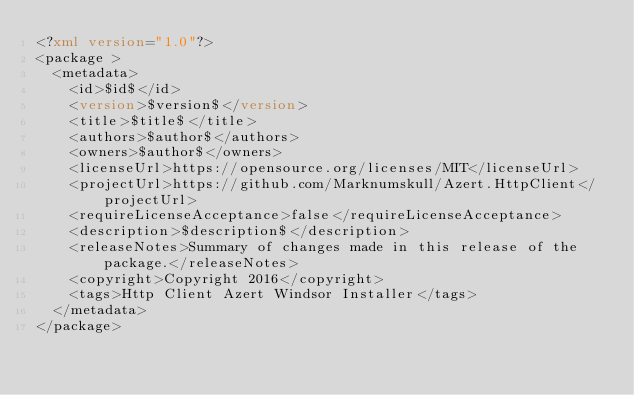<code> <loc_0><loc_0><loc_500><loc_500><_XML_><?xml version="1.0"?>
<package >
  <metadata>
    <id>$id$</id>
    <version>$version$</version>
    <title>$title$</title>
    <authors>$author$</authors>
    <owners>$author$</owners>
    <licenseUrl>https://opensource.org/licenses/MIT</licenseUrl>
    <projectUrl>https://github.com/Marknumskull/Azert.HttpClient</projectUrl>
    <requireLicenseAcceptance>false</requireLicenseAcceptance>
    <description>$description$</description>
    <releaseNotes>Summary of changes made in this release of the package.</releaseNotes>
    <copyright>Copyright 2016</copyright>
    <tags>Http Client Azert Windsor Installer</tags>
  </metadata>
</package>
</code> 